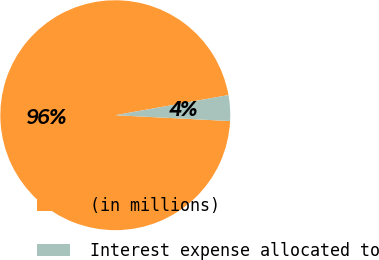Convert chart. <chart><loc_0><loc_0><loc_500><loc_500><pie_chart><fcel>(in millions)<fcel>Interest expense allocated to<nl><fcel>96.39%<fcel>3.61%<nl></chart> 